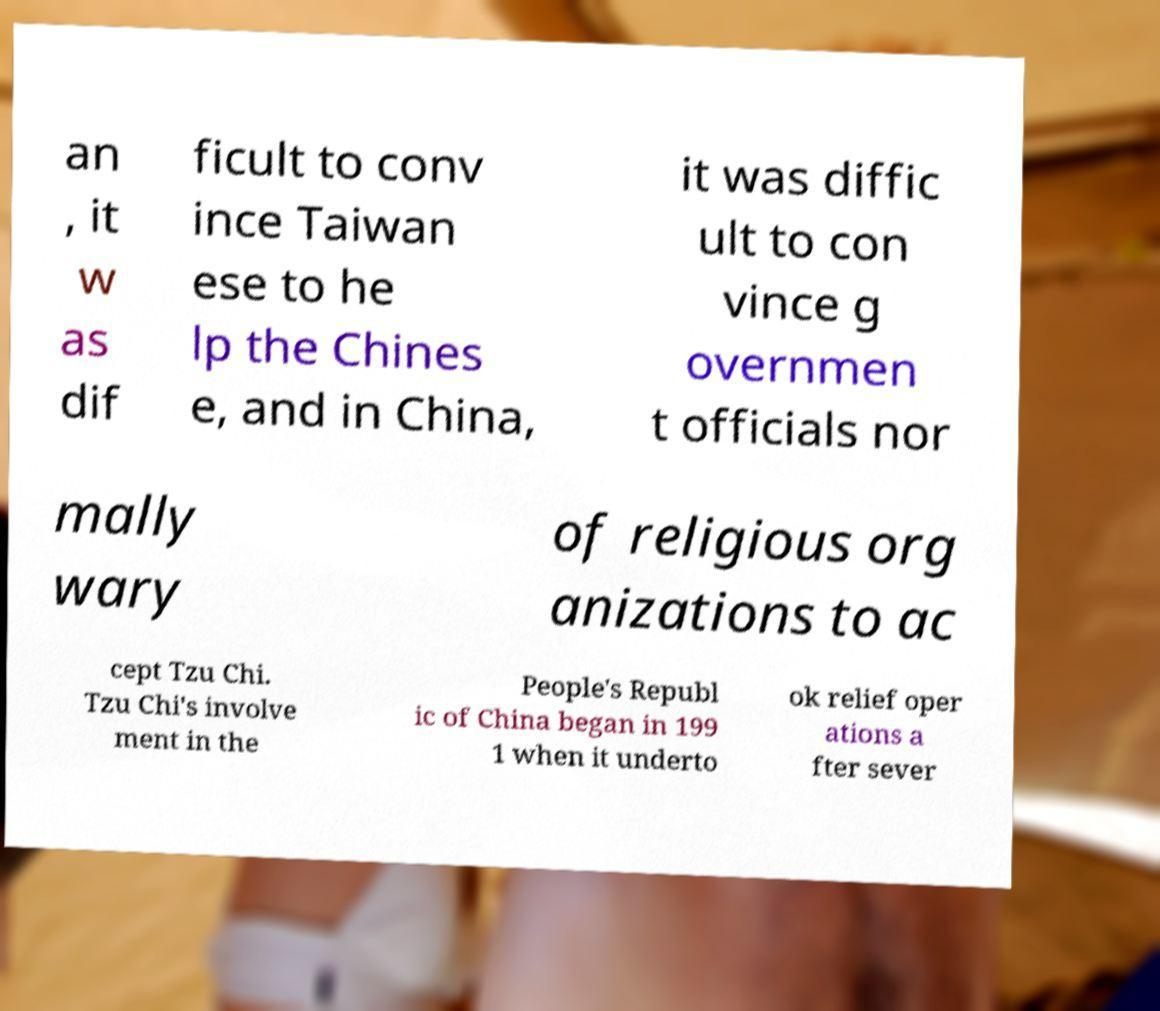Please identify and transcribe the text found in this image. an , it w as dif ficult to conv ince Taiwan ese to he lp the Chines e, and in China, it was diffic ult to con vince g overnmen t officials nor mally wary of religious org anizations to ac cept Tzu Chi. Tzu Chi's involve ment in the People's Republ ic of China began in 199 1 when it underto ok relief oper ations a fter sever 